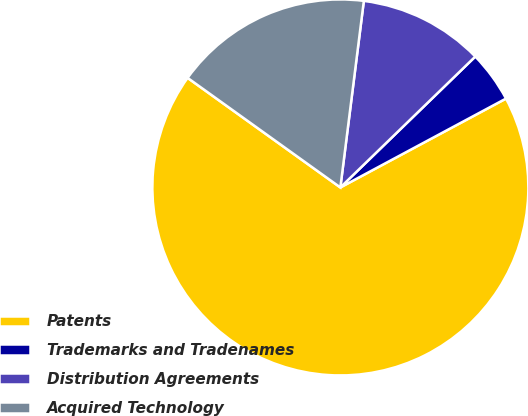Convert chart. <chart><loc_0><loc_0><loc_500><loc_500><pie_chart><fcel>Patents<fcel>Trademarks and Tradenames<fcel>Distribution Agreements<fcel>Acquired Technology<nl><fcel>67.74%<fcel>4.42%<fcel>10.75%<fcel>17.09%<nl></chart> 